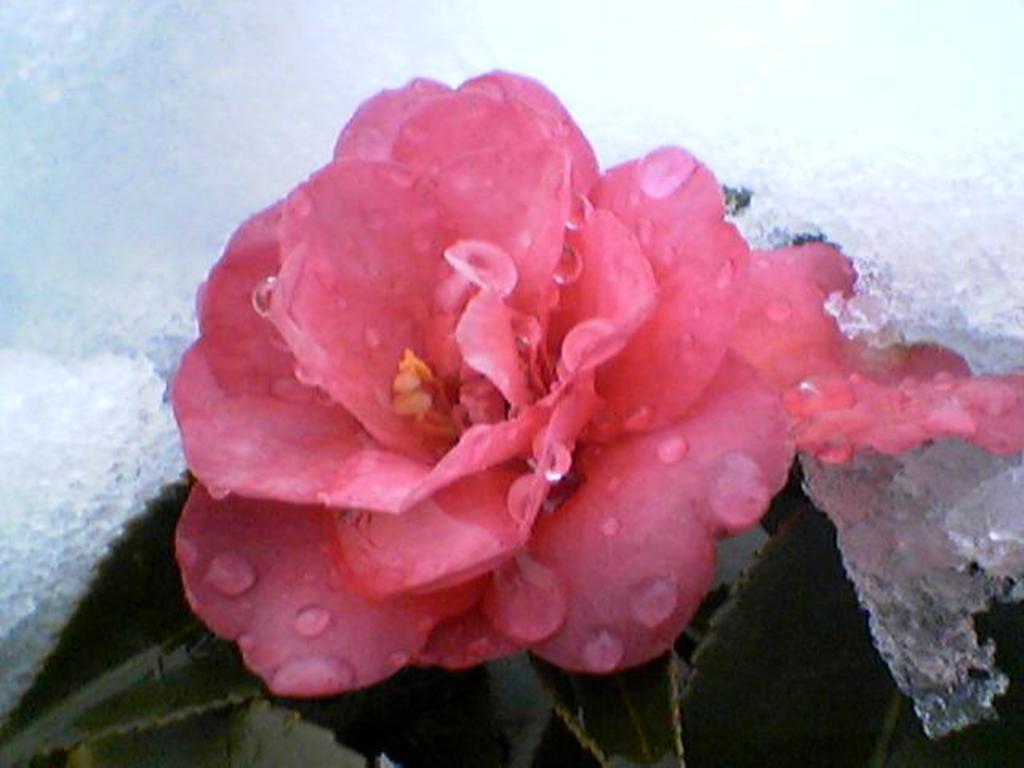In one or two sentences, can you explain what this image depicts? In this image we can see rose flower with leaves. Also there is ice. And we can see water droplets. 